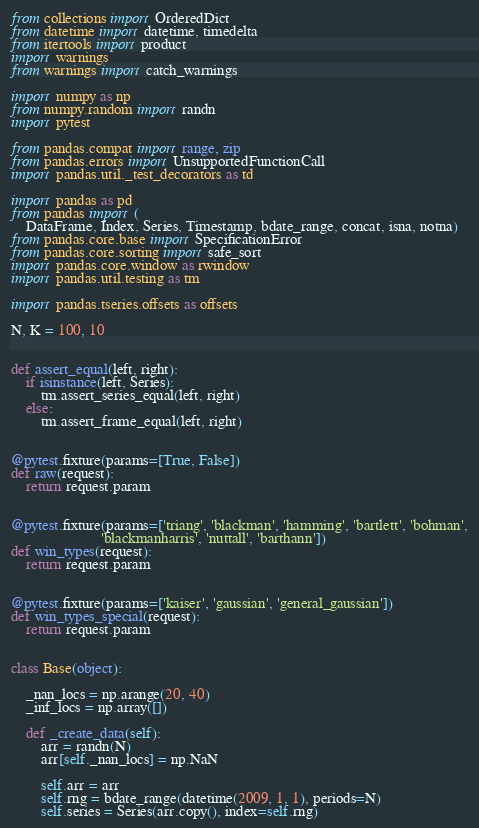Convert code to text. <code><loc_0><loc_0><loc_500><loc_500><_Python_>from collections import OrderedDict
from datetime import datetime, timedelta
from itertools import product
import warnings
from warnings import catch_warnings

import numpy as np
from numpy.random import randn
import pytest

from pandas.compat import range, zip
from pandas.errors import UnsupportedFunctionCall
import pandas.util._test_decorators as td

import pandas as pd
from pandas import (
    DataFrame, Index, Series, Timestamp, bdate_range, concat, isna, notna)
from pandas.core.base import SpecificationError
from pandas.core.sorting import safe_sort
import pandas.core.window as rwindow
import pandas.util.testing as tm

import pandas.tseries.offsets as offsets

N, K = 100, 10


def assert_equal(left, right):
    if isinstance(left, Series):
        tm.assert_series_equal(left, right)
    else:
        tm.assert_frame_equal(left, right)


@pytest.fixture(params=[True, False])
def raw(request):
    return request.param


@pytest.fixture(params=['triang', 'blackman', 'hamming', 'bartlett', 'bohman',
                        'blackmanharris', 'nuttall', 'barthann'])
def win_types(request):
    return request.param


@pytest.fixture(params=['kaiser', 'gaussian', 'general_gaussian'])
def win_types_special(request):
    return request.param


class Base(object):

    _nan_locs = np.arange(20, 40)
    _inf_locs = np.array([])

    def _create_data(self):
        arr = randn(N)
        arr[self._nan_locs] = np.NaN

        self.arr = arr
        self.rng = bdate_range(datetime(2009, 1, 1), periods=N)
        self.series = Series(arr.copy(), index=self.rng)</code> 